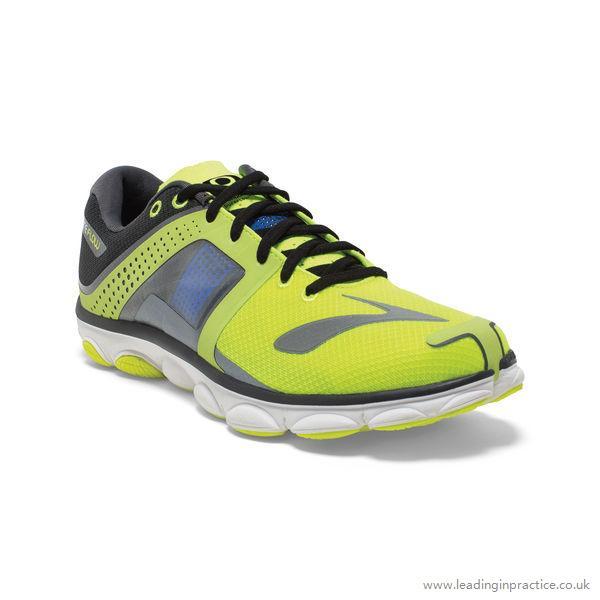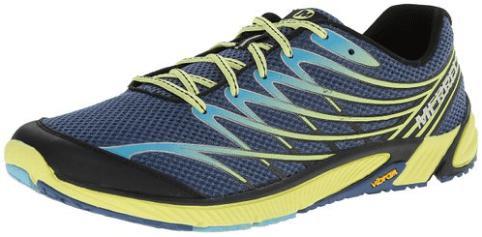The first image is the image on the left, the second image is the image on the right. For the images displayed, is the sentence "The left image contains a sports show who's toe is facing towards the right." factually correct? Answer yes or no. Yes. The first image is the image on the left, the second image is the image on the right. Evaluate the accuracy of this statement regarding the images: "Each image shows a single sneaker, and right and left images are posed heel to heel.". Is it true? Answer yes or no. No. 